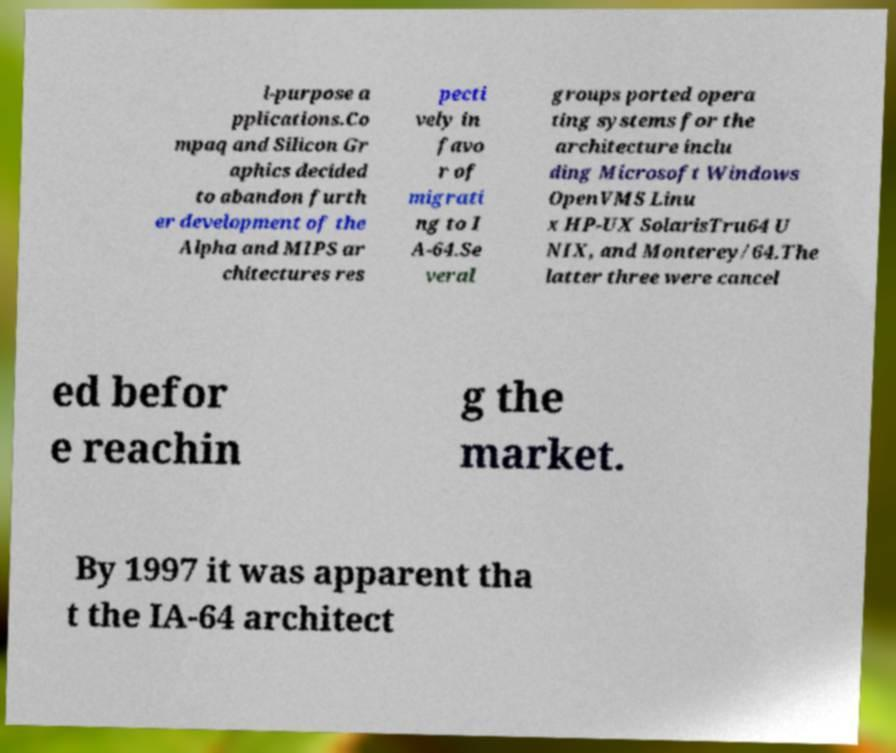Can you read and provide the text displayed in the image?This photo seems to have some interesting text. Can you extract and type it out for me? l-purpose a pplications.Co mpaq and Silicon Gr aphics decided to abandon furth er development of the Alpha and MIPS ar chitectures res pecti vely in favo r of migrati ng to I A-64.Se veral groups ported opera ting systems for the architecture inclu ding Microsoft Windows OpenVMS Linu x HP-UX SolarisTru64 U NIX, and Monterey/64.The latter three were cancel ed befor e reachin g the market. By 1997 it was apparent tha t the IA-64 architect 